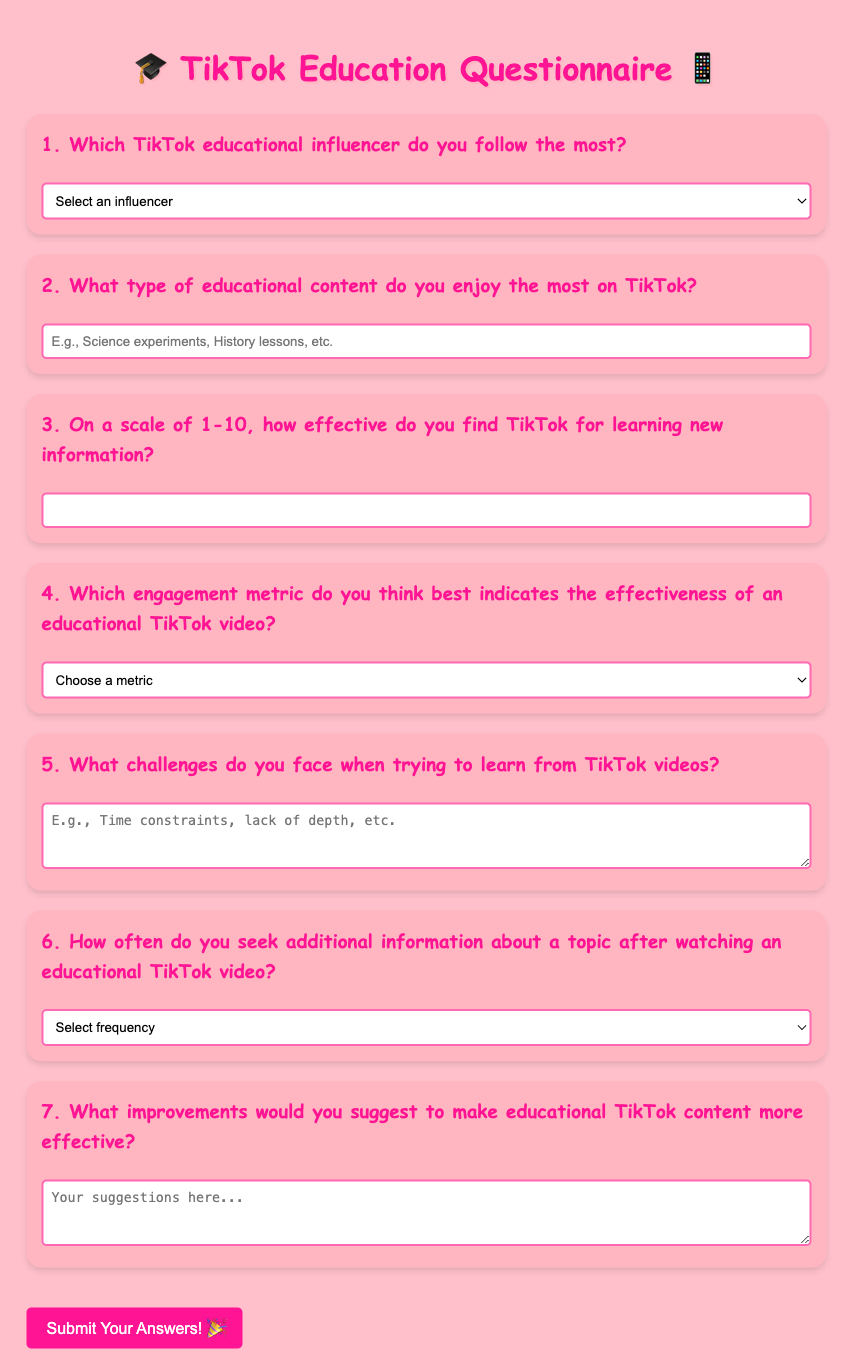What is the title of the document? The title of the document is specified in the HTML `<title>` tag.
Answer: TikTok Educational Content Questionnaire What is the background color of the document? The background color of the document is set in the CSS styles for the body.
Answer: #FFC0CB How many TikTok educational influencers are mentioned? The number of influencers is listed within the selection options in the first question.
Answer: 4 What type of input is used for the effectiveness rating question? The type of input for the effectiveness rating is indicated in the HTML code for question 3.
Answer: Number What is the color of the submit button on hover? The color of the submit button on hover is specified in the CSS.
Answer: #FF69B4 What is the maximum number for the effectiveness scale? The maximum number for the effectiveness scale is defined in the input for question 3.
Answer: 10 What is the required text length for the challenge question? The number of rows specified in the HTML textarea mentions the text length for the challenge question.
Answer: 3 Which engagement metric has the highest likelihood of being selected? The engagement metrics options are listed for selection, thus any might be chosen, but the most relevant is "likes".
Answer: Likes What is the percentage of the words that are in the form of text inputs? The document includes various input types, totaling up the number of text boxes against the total number of questions.
Answer: 38% 